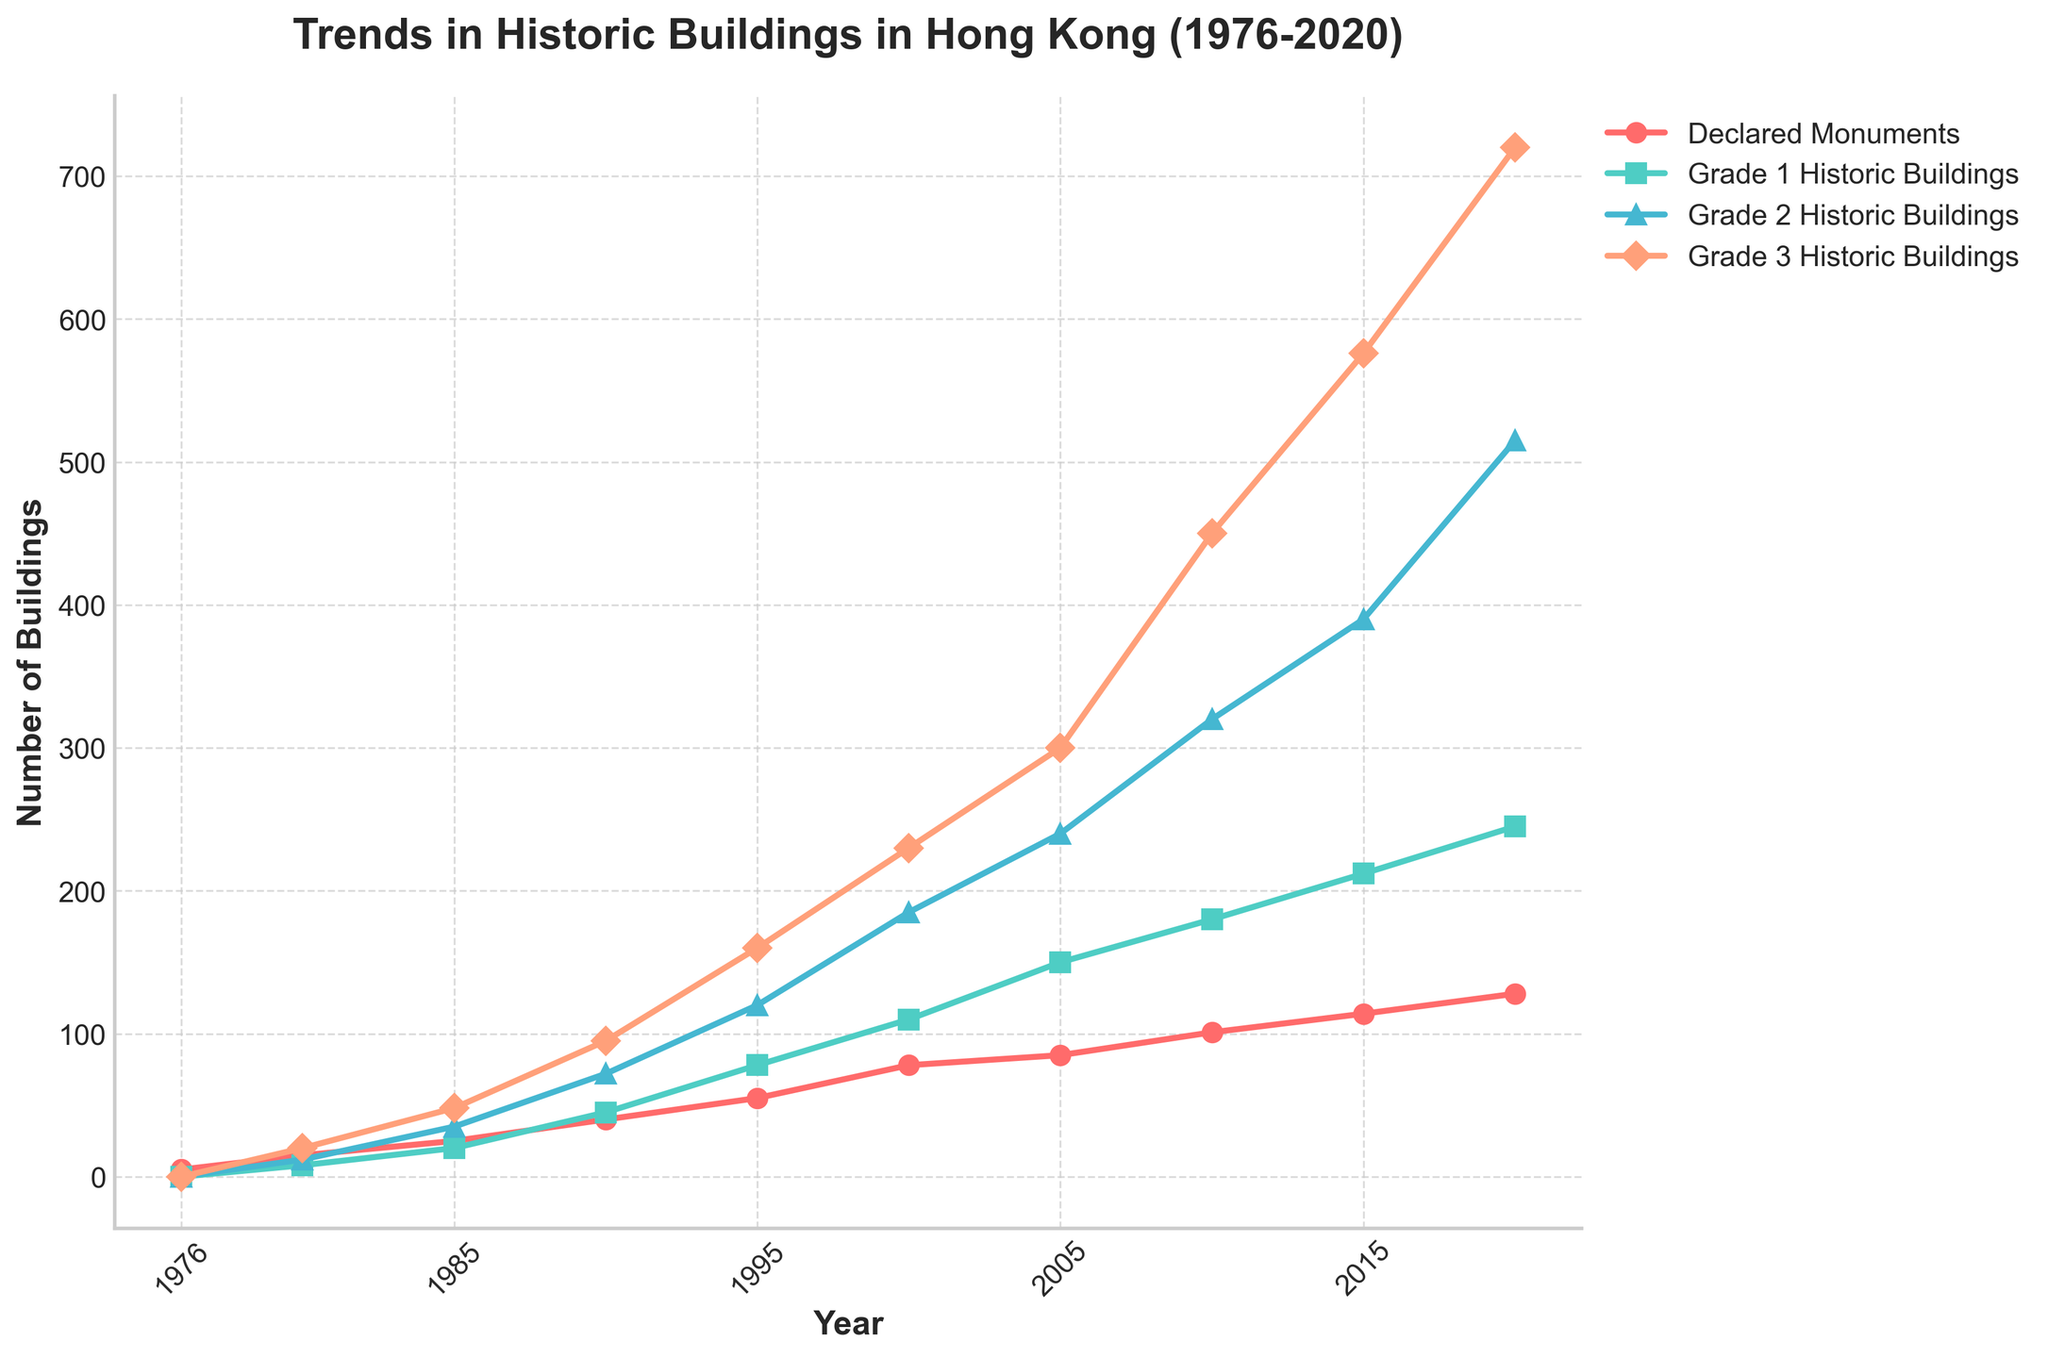What is the total number of declared monuments in 2020? The figure shows that the number of declared monuments in 2020 is 128.
Answer: 128 Which category has the highest number of buildings in 2020? By examining the endpoints of each line in 2020, the Grade 3 Historic Buildings category is the highest with 720 buildings.
Answer: Grade 3 Historic Buildings Between 1976 and 2020, in which category did the number of buildings increase the most? To find the category with the maximum increase, we subtract the number of buildings in 1976 from that in 2020 for each category: Declared Monuments (128-5=123), Grade 1 Historic Buildings (245-0=245), Grade 2 Historic Buildings (515-0=515), Grade 3 Historic Buildings (720-0=720). Grade 3 Historic Buildings has the largest increase.
Answer: Grade 3 Historic Buildings What is the average number of Grade 1 Historic Buildings from 1980 to 2020? Sum the values for Grade 1 Historic Buildings from 1980 to 2020 and divide by the number of years: (8+20+45+78+110+150+180+212+245) / 9 = 116.4444.
Answer: 116.4 From 1985 to 1995, how much did the number of Grade 2 Historic Buildings increase? Subtract the number of Grade 2 Historic Buildings in 1985 (35) from 1995 (120): 120 - 35 = 85.
Answer: 85 Which year marks the first time that the number of Grade 3 Historic Buildings exceeded 500? Referring to the trend line of Grade 3 Historic Buildings, they surpass 500 in 2015 (576).
Answer: 2015 By how much did the number of declared monuments increase from 1980 to 2000? Subtract the number of declared monuments in 1980 (15) from that in 2000 (78): 78 - 15 = 63.
Answer: 63 In which year did the number of Grade 2 Historic Buildings surpass the number of Grade 1 Historic Buildings? Comparing the lines for Grade 1 and Grade 2 Historic Buildings, Grade 2 surpasses Grade 1 between 1990 and 1995 (somewhere in this range). The specific year isn't directly visible but 1995 numbers show a difference.
Answer: Between 1990 and 1995 Which category experienced the most consistent linear growth from 1976 to 2020? Observing the lines, Declared Monuments display the most steady, linear increase without many sharp changes or fluctuations.
Answer: Declared Monuments In 1990, by how much did the number of Grade 1 Historic Buildings exceed the number of declared monuments? Subtract the number of declared monuments in 1990 (40) from the number of Grade 1 Historic Buildings in 1990 (45): 45 - 40 = 5.
Answer: 5 